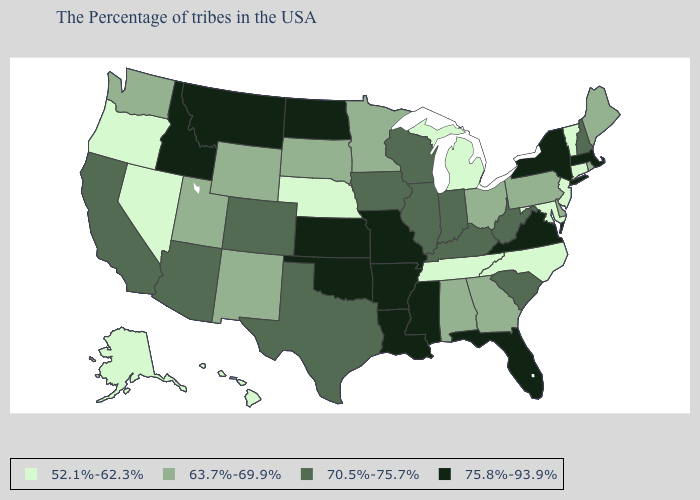Among the states that border Delaware , which have the lowest value?
Give a very brief answer. New Jersey, Maryland. Name the states that have a value in the range 52.1%-62.3%?
Be succinct. Vermont, Connecticut, New Jersey, Maryland, North Carolina, Michigan, Tennessee, Nebraska, Nevada, Oregon, Alaska, Hawaii. How many symbols are there in the legend?
Give a very brief answer. 4. Name the states that have a value in the range 70.5%-75.7%?
Write a very short answer. New Hampshire, South Carolina, West Virginia, Kentucky, Indiana, Wisconsin, Illinois, Iowa, Texas, Colorado, Arizona, California. Is the legend a continuous bar?
Be succinct. No. Which states have the lowest value in the Northeast?
Concise answer only. Vermont, Connecticut, New Jersey. Name the states that have a value in the range 75.8%-93.9%?
Concise answer only. Massachusetts, New York, Virginia, Florida, Mississippi, Louisiana, Missouri, Arkansas, Kansas, Oklahoma, North Dakota, Montana, Idaho. Name the states that have a value in the range 70.5%-75.7%?
Short answer required. New Hampshire, South Carolina, West Virginia, Kentucky, Indiana, Wisconsin, Illinois, Iowa, Texas, Colorado, Arizona, California. What is the value of South Carolina?
Give a very brief answer. 70.5%-75.7%. What is the value of Kansas?
Short answer required. 75.8%-93.9%. Does Maine have a higher value than Vermont?
Quick response, please. Yes. What is the highest value in the Northeast ?
Write a very short answer. 75.8%-93.9%. Does Wyoming have a higher value than Washington?
Write a very short answer. No. Name the states that have a value in the range 52.1%-62.3%?
Concise answer only. Vermont, Connecticut, New Jersey, Maryland, North Carolina, Michigan, Tennessee, Nebraska, Nevada, Oregon, Alaska, Hawaii. Name the states that have a value in the range 52.1%-62.3%?
Concise answer only. Vermont, Connecticut, New Jersey, Maryland, North Carolina, Michigan, Tennessee, Nebraska, Nevada, Oregon, Alaska, Hawaii. 